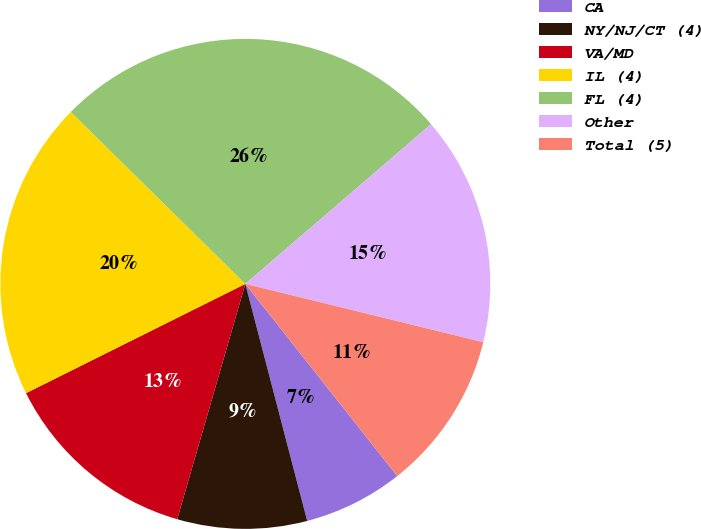Convert chart. <chart><loc_0><loc_0><loc_500><loc_500><pie_chart><fcel>CA<fcel>NY/NJ/CT (4)<fcel>VA/MD<fcel>IL (4)<fcel>FL (4)<fcel>Other<fcel>Total (5)<nl><fcel>6.58%<fcel>8.55%<fcel>13.16%<fcel>19.74%<fcel>26.32%<fcel>15.13%<fcel>10.53%<nl></chart> 